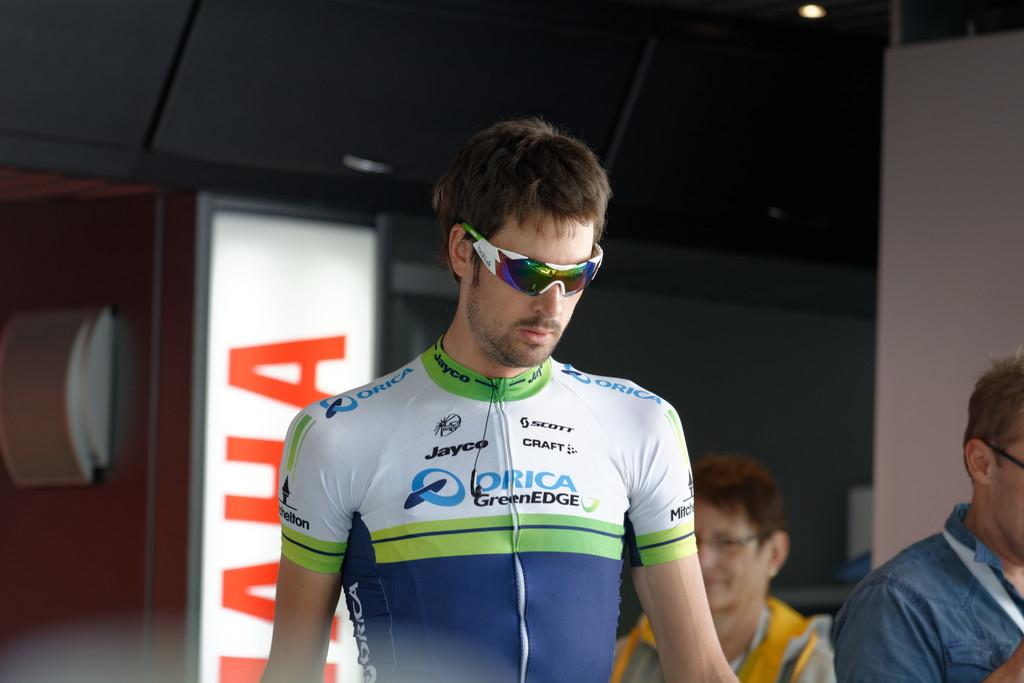What is the person in the foreground of the image wearing? The person in the foreground of the image is wearing spectacles. How many people are visible in the background of the image? There are two persons visible in the background of the image. What can be seen illuminating the scene in the image? There are lights visible in the image. What type of board is present in the background of the image? There is a light board in the background of the image. What type of hose is being used to spray the substance on the person in the image? There is no hose or substance present in the image; it only features a person with spectacles, two persons in the background, lights, and a light board. 